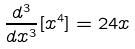Convert formula to latex. <formula><loc_0><loc_0><loc_500><loc_500>\frac { d ^ { 3 } } { d x ^ { 3 } } [ x ^ { 4 } ] = 2 4 x</formula> 